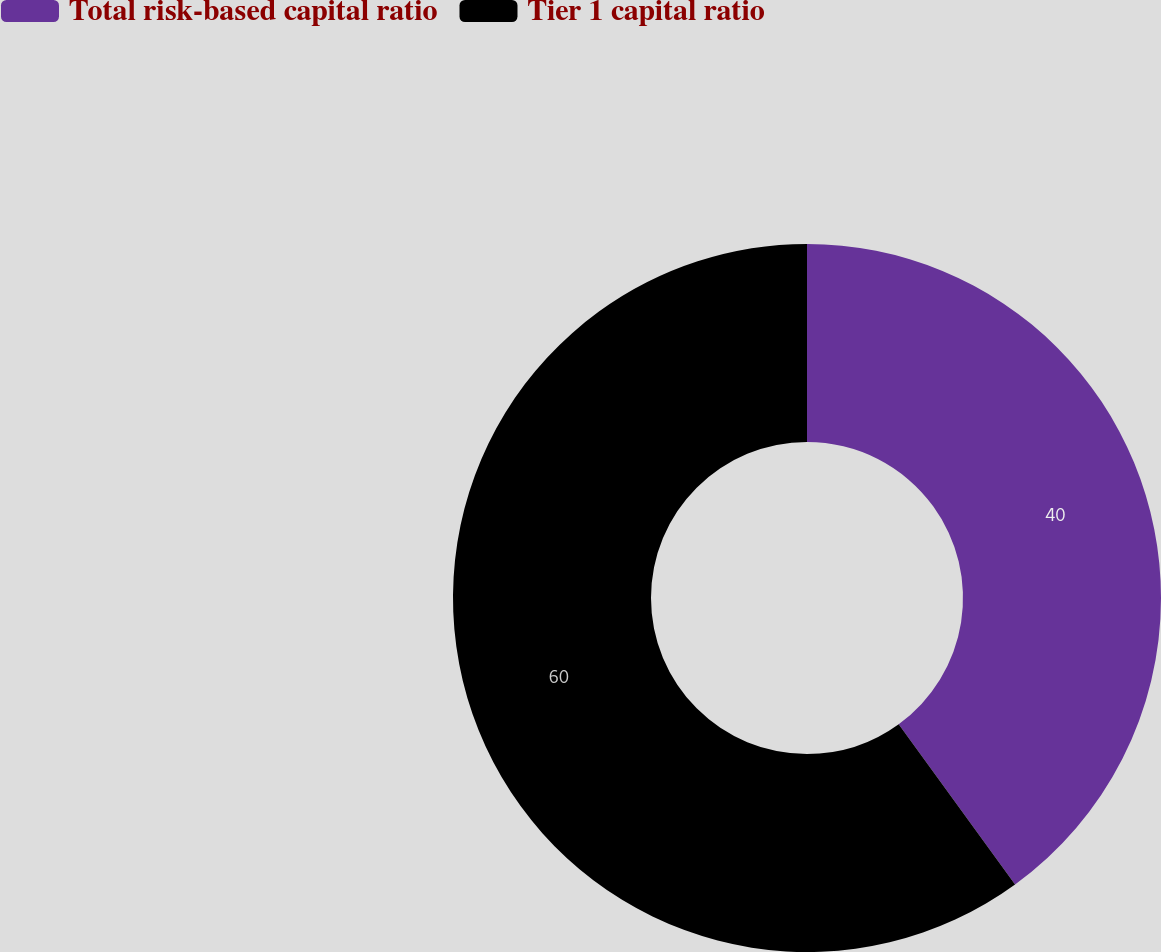<chart> <loc_0><loc_0><loc_500><loc_500><pie_chart><fcel>Total risk-based capital ratio<fcel>Tier 1 capital ratio<nl><fcel>40.0%<fcel>60.0%<nl></chart> 